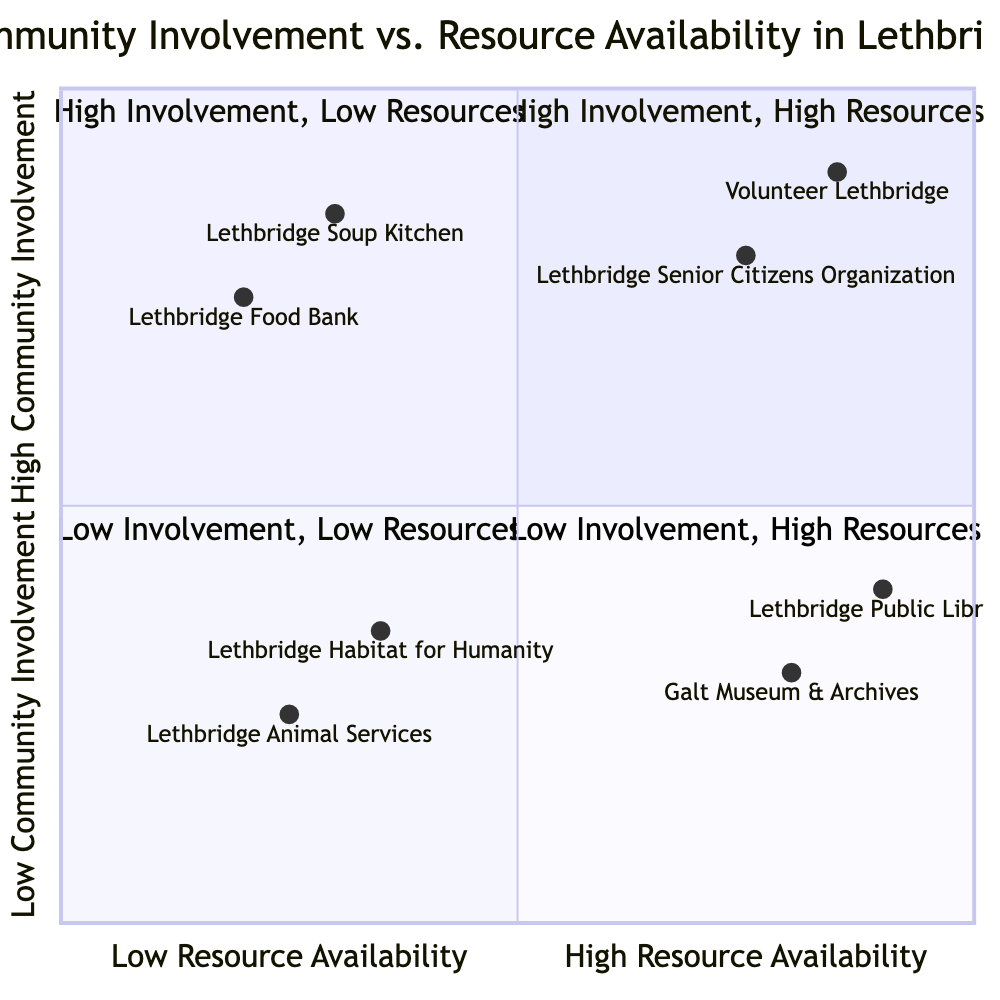What organizations are in the high community involvement, high resources quadrant? By inspecting the diagram, we can identify the organizations located in the first quadrant, which represents high community involvement and high resource availability. The names listed there are "Lethbridge Senior Citizens Organization" and "Volunteer Lethbridge."
Answer: Lethbridge Senior Citizens Organization, Volunteer Lethbridge How many organizations are in the low community involvement, low resources quadrant? To find the answer, we count the organizations that fall into the quadrant represented as low community involvement and low resource availability. There are two organizations: "Lethbridge Habitat for Humanity" and "Lethbridge Animal Services."
Answer: 2 Which organization has high community involvement but low resource availability? We look at the second quadrant where community involvement is high, but resource availability is low. The organizations in this quadrant are "Lethbridge Soup Kitchen" and "Lethbridge Food Bank."
Answer: Lethbridge Soup Kitchen, Lethbridge Food Bank What is the highest community involvement value shown in the chart? The community involvement values of organizations are located on the Y-axis. By examining the chart, the organizations "Lethbridge Senior Citizens Organization" and "Volunteer Lethbridge" have the highest values, which are both above 0.8, specifically 0.9 and 0.85 respectively. The highest value is 0.9.
Answer: 0.9 How many organizations have high resource availability? We analyze the third and fourth quadrants, where organizations are labeled with high resource availability. The organizations are "Galt Museum & Archives," "Lethbridge Public Library," "Lethbridge Senior Citizens Organization," and "Volunteer Lethbridge." Thus, there are four organizations that can be classified as high resource availability.
Answer: 4 Which organization is the least involved with the community? To determine this, we look for the organization at the lowest position on the Y-axis in the quadrant chart, indicating low community involvement. "Lethbridge Animal Services" has the lowest community involvement value of 0.25.
Answer: Lethbridge Animal Services Which quadrant has organizations that are both low in community involvement and low in resource availability? We check the quadrant layout to identify the quadrants. The third quadrant is designated for organizations that have both low community involvement and low resource availability. The organizations included are "Lethbridge Habitat for Humanity" and "Lethbridge Animal Services."
Answer: Low community involvement, low resources quadrant (3rd quadrant) What is the lowest resource availability value shown in the chart? We will review the resource availability values of each organization by looking at the X-axis. The organization with the lowest resource availability value, which is for "Lethbridge Animal Services," shows a value of 0.25.
Answer: 0.25 